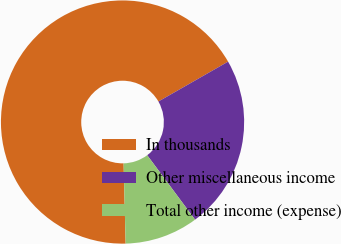Convert chart to OTSL. <chart><loc_0><loc_0><loc_500><loc_500><pie_chart><fcel>In thousands<fcel>Other miscellaneous income<fcel>Total other income (expense)<nl><fcel>67.13%<fcel>23.1%<fcel>9.76%<nl></chart> 